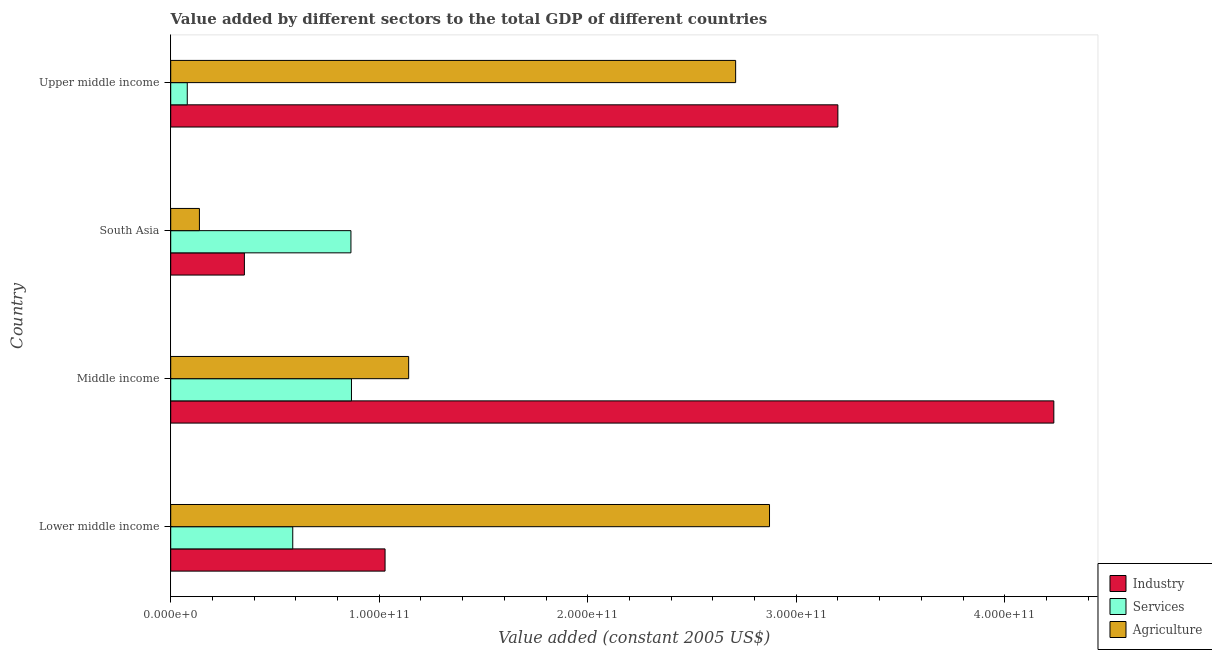How many bars are there on the 3rd tick from the top?
Provide a succinct answer. 3. In how many cases, is the number of bars for a given country not equal to the number of legend labels?
Offer a very short reply. 0. What is the value added by industrial sector in Lower middle income?
Your answer should be very brief. 1.03e+11. Across all countries, what is the maximum value added by services?
Your answer should be compact. 8.67e+1. Across all countries, what is the minimum value added by industrial sector?
Your answer should be very brief. 3.53e+1. In which country was the value added by agricultural sector maximum?
Keep it short and to the point. Lower middle income. What is the total value added by industrial sector in the graph?
Your answer should be very brief. 8.82e+11. What is the difference between the value added by services in Middle income and that in South Asia?
Make the answer very short. 2.62e+08. What is the difference between the value added by industrial sector in Lower middle income and the value added by agricultural sector in Upper middle income?
Keep it short and to the point. -1.68e+11. What is the average value added by services per country?
Give a very brief answer. 5.99e+1. What is the difference between the value added by industrial sector and value added by agricultural sector in Upper middle income?
Provide a succinct answer. 4.90e+1. In how many countries, is the value added by agricultural sector greater than 180000000000 US$?
Give a very brief answer. 2. What is the ratio of the value added by industrial sector in Lower middle income to that in Middle income?
Your answer should be very brief. 0.24. Is the value added by industrial sector in Middle income less than that in South Asia?
Offer a terse response. No. Is the difference between the value added by services in South Asia and Upper middle income greater than the difference between the value added by industrial sector in South Asia and Upper middle income?
Keep it short and to the point. Yes. What is the difference between the highest and the second highest value added by services?
Make the answer very short. 2.62e+08. What is the difference between the highest and the lowest value added by services?
Your response must be concise. 7.88e+1. What does the 2nd bar from the top in South Asia represents?
Your answer should be very brief. Services. What does the 3rd bar from the bottom in South Asia represents?
Make the answer very short. Agriculture. How many bars are there?
Give a very brief answer. 12. Are all the bars in the graph horizontal?
Make the answer very short. Yes. How many countries are there in the graph?
Offer a very short reply. 4. What is the difference between two consecutive major ticks on the X-axis?
Offer a terse response. 1.00e+11. Where does the legend appear in the graph?
Keep it short and to the point. Bottom right. How are the legend labels stacked?
Make the answer very short. Vertical. What is the title of the graph?
Give a very brief answer. Value added by different sectors to the total GDP of different countries. What is the label or title of the X-axis?
Offer a terse response. Value added (constant 2005 US$). What is the label or title of the Y-axis?
Give a very brief answer. Country. What is the Value added (constant 2005 US$) in Industry in Lower middle income?
Your answer should be compact. 1.03e+11. What is the Value added (constant 2005 US$) in Services in Lower middle income?
Make the answer very short. 5.85e+1. What is the Value added (constant 2005 US$) of Agriculture in Lower middle income?
Offer a very short reply. 2.87e+11. What is the Value added (constant 2005 US$) in Industry in Middle income?
Provide a short and direct response. 4.24e+11. What is the Value added (constant 2005 US$) of Services in Middle income?
Offer a very short reply. 8.67e+1. What is the Value added (constant 2005 US$) of Agriculture in Middle income?
Your answer should be very brief. 1.14e+11. What is the Value added (constant 2005 US$) in Industry in South Asia?
Provide a short and direct response. 3.53e+1. What is the Value added (constant 2005 US$) in Services in South Asia?
Provide a short and direct response. 8.64e+1. What is the Value added (constant 2005 US$) of Agriculture in South Asia?
Offer a terse response. 1.38e+1. What is the Value added (constant 2005 US$) in Industry in Upper middle income?
Your answer should be compact. 3.20e+11. What is the Value added (constant 2005 US$) of Services in Upper middle income?
Provide a succinct answer. 7.94e+09. What is the Value added (constant 2005 US$) of Agriculture in Upper middle income?
Your response must be concise. 2.71e+11. Across all countries, what is the maximum Value added (constant 2005 US$) of Industry?
Give a very brief answer. 4.24e+11. Across all countries, what is the maximum Value added (constant 2005 US$) in Services?
Provide a succinct answer. 8.67e+1. Across all countries, what is the maximum Value added (constant 2005 US$) in Agriculture?
Offer a terse response. 2.87e+11. Across all countries, what is the minimum Value added (constant 2005 US$) of Industry?
Your answer should be compact. 3.53e+1. Across all countries, what is the minimum Value added (constant 2005 US$) in Services?
Provide a succinct answer. 7.94e+09. Across all countries, what is the minimum Value added (constant 2005 US$) in Agriculture?
Your answer should be compact. 1.38e+1. What is the total Value added (constant 2005 US$) of Industry in the graph?
Offer a terse response. 8.82e+11. What is the total Value added (constant 2005 US$) of Services in the graph?
Make the answer very short. 2.40e+11. What is the total Value added (constant 2005 US$) of Agriculture in the graph?
Offer a very short reply. 6.86e+11. What is the difference between the Value added (constant 2005 US$) of Industry in Lower middle income and that in Middle income?
Offer a terse response. -3.21e+11. What is the difference between the Value added (constant 2005 US$) in Services in Lower middle income and that in Middle income?
Keep it short and to the point. -2.82e+1. What is the difference between the Value added (constant 2005 US$) in Agriculture in Lower middle income and that in Middle income?
Make the answer very short. 1.73e+11. What is the difference between the Value added (constant 2005 US$) of Industry in Lower middle income and that in South Asia?
Offer a terse response. 6.75e+1. What is the difference between the Value added (constant 2005 US$) of Services in Lower middle income and that in South Asia?
Provide a short and direct response. -2.79e+1. What is the difference between the Value added (constant 2005 US$) in Agriculture in Lower middle income and that in South Asia?
Ensure brevity in your answer.  2.73e+11. What is the difference between the Value added (constant 2005 US$) of Industry in Lower middle income and that in Upper middle income?
Provide a short and direct response. -2.17e+11. What is the difference between the Value added (constant 2005 US$) of Services in Lower middle income and that in Upper middle income?
Ensure brevity in your answer.  5.06e+1. What is the difference between the Value added (constant 2005 US$) in Agriculture in Lower middle income and that in Upper middle income?
Provide a succinct answer. 1.62e+1. What is the difference between the Value added (constant 2005 US$) of Industry in Middle income and that in South Asia?
Provide a succinct answer. 3.88e+11. What is the difference between the Value added (constant 2005 US$) of Services in Middle income and that in South Asia?
Offer a very short reply. 2.62e+08. What is the difference between the Value added (constant 2005 US$) in Agriculture in Middle income and that in South Asia?
Your answer should be compact. 1.00e+11. What is the difference between the Value added (constant 2005 US$) of Industry in Middle income and that in Upper middle income?
Offer a terse response. 1.04e+11. What is the difference between the Value added (constant 2005 US$) in Services in Middle income and that in Upper middle income?
Offer a terse response. 7.88e+1. What is the difference between the Value added (constant 2005 US$) of Agriculture in Middle income and that in Upper middle income?
Provide a short and direct response. -1.57e+11. What is the difference between the Value added (constant 2005 US$) of Industry in South Asia and that in Upper middle income?
Keep it short and to the point. -2.85e+11. What is the difference between the Value added (constant 2005 US$) of Services in South Asia and that in Upper middle income?
Provide a succinct answer. 7.85e+1. What is the difference between the Value added (constant 2005 US$) of Agriculture in South Asia and that in Upper middle income?
Ensure brevity in your answer.  -2.57e+11. What is the difference between the Value added (constant 2005 US$) in Industry in Lower middle income and the Value added (constant 2005 US$) in Services in Middle income?
Your response must be concise. 1.61e+1. What is the difference between the Value added (constant 2005 US$) in Industry in Lower middle income and the Value added (constant 2005 US$) in Agriculture in Middle income?
Offer a terse response. -1.13e+1. What is the difference between the Value added (constant 2005 US$) of Services in Lower middle income and the Value added (constant 2005 US$) of Agriculture in Middle income?
Keep it short and to the point. -5.56e+1. What is the difference between the Value added (constant 2005 US$) of Industry in Lower middle income and the Value added (constant 2005 US$) of Services in South Asia?
Your answer should be very brief. 1.64e+1. What is the difference between the Value added (constant 2005 US$) of Industry in Lower middle income and the Value added (constant 2005 US$) of Agriculture in South Asia?
Ensure brevity in your answer.  8.90e+1. What is the difference between the Value added (constant 2005 US$) in Services in Lower middle income and the Value added (constant 2005 US$) in Agriculture in South Asia?
Offer a very short reply. 4.48e+1. What is the difference between the Value added (constant 2005 US$) in Industry in Lower middle income and the Value added (constant 2005 US$) in Services in Upper middle income?
Your answer should be compact. 9.49e+1. What is the difference between the Value added (constant 2005 US$) of Industry in Lower middle income and the Value added (constant 2005 US$) of Agriculture in Upper middle income?
Give a very brief answer. -1.68e+11. What is the difference between the Value added (constant 2005 US$) of Services in Lower middle income and the Value added (constant 2005 US$) of Agriculture in Upper middle income?
Offer a very short reply. -2.12e+11. What is the difference between the Value added (constant 2005 US$) in Industry in Middle income and the Value added (constant 2005 US$) in Services in South Asia?
Your answer should be compact. 3.37e+11. What is the difference between the Value added (constant 2005 US$) in Industry in Middle income and the Value added (constant 2005 US$) in Agriculture in South Asia?
Your answer should be very brief. 4.10e+11. What is the difference between the Value added (constant 2005 US$) of Services in Middle income and the Value added (constant 2005 US$) of Agriculture in South Asia?
Your answer should be very brief. 7.29e+1. What is the difference between the Value added (constant 2005 US$) in Industry in Middle income and the Value added (constant 2005 US$) in Services in Upper middle income?
Keep it short and to the point. 4.16e+11. What is the difference between the Value added (constant 2005 US$) of Industry in Middle income and the Value added (constant 2005 US$) of Agriculture in Upper middle income?
Provide a short and direct response. 1.53e+11. What is the difference between the Value added (constant 2005 US$) of Services in Middle income and the Value added (constant 2005 US$) of Agriculture in Upper middle income?
Offer a terse response. -1.84e+11. What is the difference between the Value added (constant 2005 US$) of Industry in South Asia and the Value added (constant 2005 US$) of Services in Upper middle income?
Make the answer very short. 2.74e+1. What is the difference between the Value added (constant 2005 US$) in Industry in South Asia and the Value added (constant 2005 US$) in Agriculture in Upper middle income?
Offer a terse response. -2.36e+11. What is the difference between the Value added (constant 2005 US$) of Services in South Asia and the Value added (constant 2005 US$) of Agriculture in Upper middle income?
Ensure brevity in your answer.  -1.85e+11. What is the average Value added (constant 2005 US$) in Industry per country?
Your answer should be very brief. 2.20e+11. What is the average Value added (constant 2005 US$) in Services per country?
Ensure brevity in your answer.  5.99e+1. What is the average Value added (constant 2005 US$) of Agriculture per country?
Your answer should be compact. 1.71e+11. What is the difference between the Value added (constant 2005 US$) of Industry and Value added (constant 2005 US$) of Services in Lower middle income?
Give a very brief answer. 4.43e+1. What is the difference between the Value added (constant 2005 US$) in Industry and Value added (constant 2005 US$) in Agriculture in Lower middle income?
Your response must be concise. -1.84e+11. What is the difference between the Value added (constant 2005 US$) of Services and Value added (constant 2005 US$) of Agriculture in Lower middle income?
Ensure brevity in your answer.  -2.29e+11. What is the difference between the Value added (constant 2005 US$) in Industry and Value added (constant 2005 US$) in Services in Middle income?
Keep it short and to the point. 3.37e+11. What is the difference between the Value added (constant 2005 US$) of Industry and Value added (constant 2005 US$) of Agriculture in Middle income?
Offer a terse response. 3.09e+11. What is the difference between the Value added (constant 2005 US$) of Services and Value added (constant 2005 US$) of Agriculture in Middle income?
Make the answer very short. -2.74e+1. What is the difference between the Value added (constant 2005 US$) in Industry and Value added (constant 2005 US$) in Services in South Asia?
Your response must be concise. -5.11e+1. What is the difference between the Value added (constant 2005 US$) in Industry and Value added (constant 2005 US$) in Agriculture in South Asia?
Provide a short and direct response. 2.16e+1. What is the difference between the Value added (constant 2005 US$) of Services and Value added (constant 2005 US$) of Agriculture in South Asia?
Provide a succinct answer. 7.27e+1. What is the difference between the Value added (constant 2005 US$) of Industry and Value added (constant 2005 US$) of Services in Upper middle income?
Keep it short and to the point. 3.12e+11. What is the difference between the Value added (constant 2005 US$) of Industry and Value added (constant 2005 US$) of Agriculture in Upper middle income?
Offer a very short reply. 4.90e+1. What is the difference between the Value added (constant 2005 US$) in Services and Value added (constant 2005 US$) in Agriculture in Upper middle income?
Provide a succinct answer. -2.63e+11. What is the ratio of the Value added (constant 2005 US$) of Industry in Lower middle income to that in Middle income?
Give a very brief answer. 0.24. What is the ratio of the Value added (constant 2005 US$) in Services in Lower middle income to that in Middle income?
Make the answer very short. 0.68. What is the ratio of the Value added (constant 2005 US$) in Agriculture in Lower middle income to that in Middle income?
Give a very brief answer. 2.52. What is the ratio of the Value added (constant 2005 US$) in Industry in Lower middle income to that in South Asia?
Your response must be concise. 2.91. What is the ratio of the Value added (constant 2005 US$) of Services in Lower middle income to that in South Asia?
Provide a short and direct response. 0.68. What is the ratio of the Value added (constant 2005 US$) in Agriculture in Lower middle income to that in South Asia?
Make the answer very short. 20.86. What is the ratio of the Value added (constant 2005 US$) of Industry in Lower middle income to that in Upper middle income?
Offer a very short reply. 0.32. What is the ratio of the Value added (constant 2005 US$) in Services in Lower middle income to that in Upper middle income?
Provide a short and direct response. 7.37. What is the ratio of the Value added (constant 2005 US$) in Agriculture in Lower middle income to that in Upper middle income?
Make the answer very short. 1.06. What is the ratio of the Value added (constant 2005 US$) in Industry in Middle income to that in South Asia?
Ensure brevity in your answer.  11.99. What is the ratio of the Value added (constant 2005 US$) of Agriculture in Middle income to that in South Asia?
Your response must be concise. 8.29. What is the ratio of the Value added (constant 2005 US$) of Industry in Middle income to that in Upper middle income?
Provide a short and direct response. 1.32. What is the ratio of the Value added (constant 2005 US$) in Services in Middle income to that in Upper middle income?
Provide a short and direct response. 10.92. What is the ratio of the Value added (constant 2005 US$) of Agriculture in Middle income to that in Upper middle income?
Make the answer very short. 0.42. What is the ratio of the Value added (constant 2005 US$) of Industry in South Asia to that in Upper middle income?
Offer a very short reply. 0.11. What is the ratio of the Value added (constant 2005 US$) in Services in South Asia to that in Upper middle income?
Ensure brevity in your answer.  10.89. What is the ratio of the Value added (constant 2005 US$) of Agriculture in South Asia to that in Upper middle income?
Ensure brevity in your answer.  0.05. What is the difference between the highest and the second highest Value added (constant 2005 US$) of Industry?
Your answer should be compact. 1.04e+11. What is the difference between the highest and the second highest Value added (constant 2005 US$) of Services?
Keep it short and to the point. 2.62e+08. What is the difference between the highest and the second highest Value added (constant 2005 US$) in Agriculture?
Keep it short and to the point. 1.62e+1. What is the difference between the highest and the lowest Value added (constant 2005 US$) of Industry?
Offer a very short reply. 3.88e+11. What is the difference between the highest and the lowest Value added (constant 2005 US$) of Services?
Your answer should be compact. 7.88e+1. What is the difference between the highest and the lowest Value added (constant 2005 US$) in Agriculture?
Make the answer very short. 2.73e+11. 